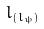Convert formula to latex. <formula><loc_0><loc_0><loc_500><loc_500>l _ { ( l _ { \psi } ) }</formula> 